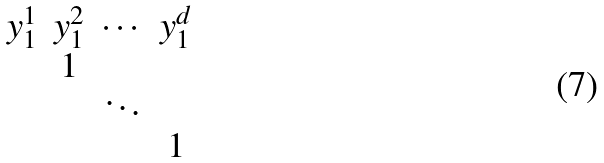Convert formula to latex. <formula><loc_0><loc_0><loc_500><loc_500>\begin{matrix} y _ { 1 } ^ { 1 } & y _ { 1 } ^ { 2 } & \cdots & y _ { 1 } ^ { d } \\ & 1 & & \\ & & \ddots & \\ & & & 1 \\ \end{matrix}</formula> 